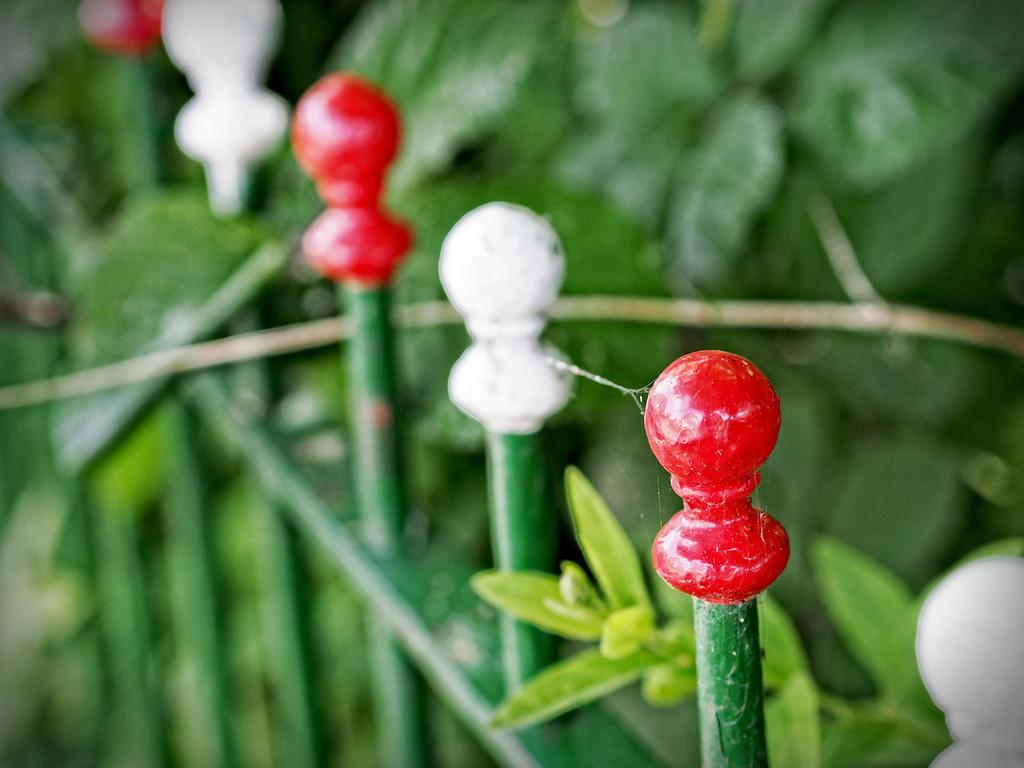What can be seen in the picture? There is a railing in the picture. What is the color of the railing? The railing is green in color. What is located behind the railing? There are plants visible behind the railing. How many legs can be seen on the fan in the image? There is no fan present in the image, so it is not possible to determine the number of legs on a fan. 